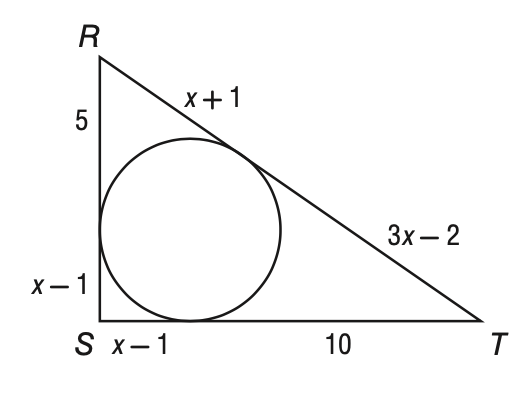Question: Triangle R S T is circumscribed about the circle below. What is the perimeter of the triangle?
Choices:
A. 33
B. 36
C. 37
D. 40
Answer with the letter. Answer: B 